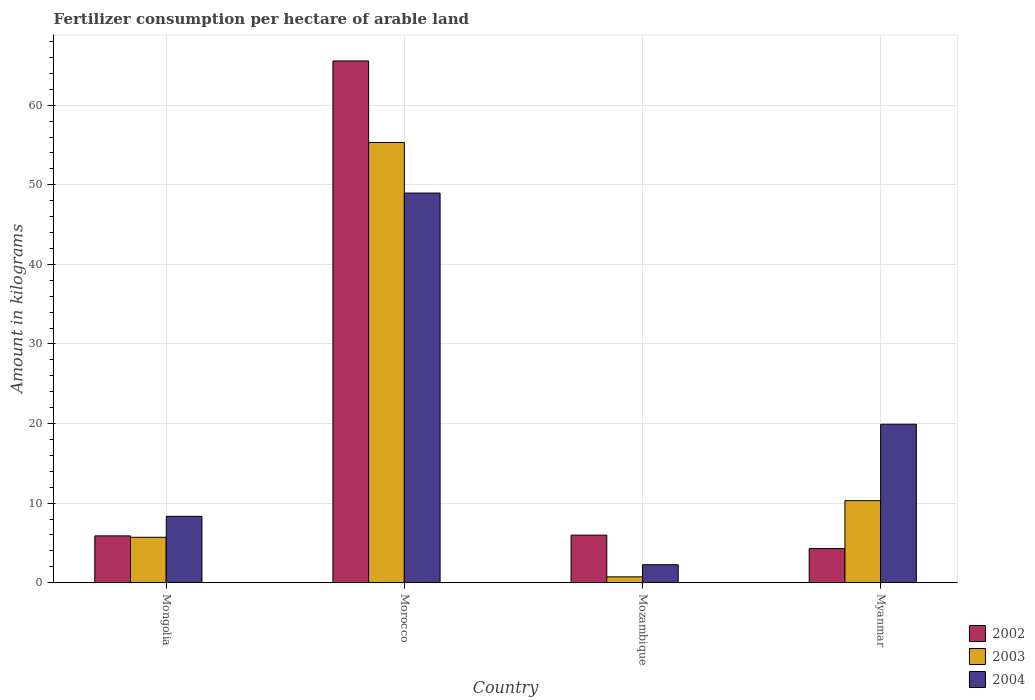How many different coloured bars are there?
Offer a terse response. 3. Are the number of bars per tick equal to the number of legend labels?
Give a very brief answer. Yes. How many bars are there on the 1st tick from the left?
Make the answer very short. 3. What is the label of the 3rd group of bars from the left?
Provide a succinct answer. Mozambique. In how many cases, is the number of bars for a given country not equal to the number of legend labels?
Keep it short and to the point. 0. What is the amount of fertilizer consumption in 2003 in Myanmar?
Give a very brief answer. 10.31. Across all countries, what is the maximum amount of fertilizer consumption in 2004?
Your answer should be compact. 48.96. Across all countries, what is the minimum amount of fertilizer consumption in 2002?
Provide a short and direct response. 4.29. In which country was the amount of fertilizer consumption in 2004 maximum?
Your answer should be very brief. Morocco. In which country was the amount of fertilizer consumption in 2004 minimum?
Offer a terse response. Mozambique. What is the total amount of fertilizer consumption in 2004 in the graph?
Your answer should be very brief. 79.47. What is the difference between the amount of fertilizer consumption in 2004 in Mongolia and that in Mozambique?
Your answer should be compact. 6.08. What is the difference between the amount of fertilizer consumption in 2003 in Morocco and the amount of fertilizer consumption in 2002 in Mongolia?
Offer a terse response. 49.43. What is the average amount of fertilizer consumption in 2002 per country?
Your answer should be very brief. 20.43. What is the difference between the amount of fertilizer consumption of/in 2003 and amount of fertilizer consumption of/in 2002 in Mozambique?
Give a very brief answer. -5.24. In how many countries, is the amount of fertilizer consumption in 2004 greater than 52 kg?
Provide a short and direct response. 0. What is the ratio of the amount of fertilizer consumption in 2003 in Morocco to that in Myanmar?
Provide a short and direct response. 5.37. Is the amount of fertilizer consumption in 2002 in Mongolia less than that in Myanmar?
Make the answer very short. No. What is the difference between the highest and the second highest amount of fertilizer consumption in 2004?
Your answer should be compact. 40.62. What is the difference between the highest and the lowest amount of fertilizer consumption in 2004?
Your response must be concise. 46.7. In how many countries, is the amount of fertilizer consumption in 2003 greater than the average amount of fertilizer consumption in 2003 taken over all countries?
Your answer should be compact. 1. Is the sum of the amount of fertilizer consumption in 2002 in Mongolia and Morocco greater than the maximum amount of fertilizer consumption in 2004 across all countries?
Give a very brief answer. Yes. What does the 3rd bar from the left in Mongolia represents?
Ensure brevity in your answer.  2004. What does the 3rd bar from the right in Myanmar represents?
Provide a succinct answer. 2002. Is it the case that in every country, the sum of the amount of fertilizer consumption in 2004 and amount of fertilizer consumption in 2002 is greater than the amount of fertilizer consumption in 2003?
Make the answer very short. Yes. What is the difference between two consecutive major ticks on the Y-axis?
Your answer should be compact. 10. Are the values on the major ticks of Y-axis written in scientific E-notation?
Your answer should be very brief. No. Does the graph contain any zero values?
Offer a very short reply. No. How many legend labels are there?
Ensure brevity in your answer.  3. What is the title of the graph?
Provide a succinct answer. Fertilizer consumption per hectare of arable land. Does "2011" appear as one of the legend labels in the graph?
Provide a succinct answer. No. What is the label or title of the Y-axis?
Make the answer very short. Amount in kilograms. What is the Amount in kilograms of 2002 in Mongolia?
Provide a short and direct response. 5.88. What is the Amount in kilograms of 2003 in Mongolia?
Offer a very short reply. 5.71. What is the Amount in kilograms in 2004 in Mongolia?
Offer a very short reply. 8.34. What is the Amount in kilograms of 2002 in Morocco?
Your answer should be very brief. 65.55. What is the Amount in kilograms of 2003 in Morocco?
Offer a terse response. 55.31. What is the Amount in kilograms of 2004 in Morocco?
Your response must be concise. 48.96. What is the Amount in kilograms of 2002 in Mozambique?
Ensure brevity in your answer.  5.98. What is the Amount in kilograms in 2003 in Mozambique?
Give a very brief answer. 0.74. What is the Amount in kilograms in 2004 in Mozambique?
Ensure brevity in your answer.  2.26. What is the Amount in kilograms of 2002 in Myanmar?
Offer a terse response. 4.29. What is the Amount in kilograms in 2003 in Myanmar?
Offer a very short reply. 10.31. What is the Amount in kilograms of 2004 in Myanmar?
Your answer should be very brief. 19.91. Across all countries, what is the maximum Amount in kilograms of 2002?
Provide a succinct answer. 65.55. Across all countries, what is the maximum Amount in kilograms of 2003?
Offer a very short reply. 55.31. Across all countries, what is the maximum Amount in kilograms of 2004?
Keep it short and to the point. 48.96. Across all countries, what is the minimum Amount in kilograms in 2002?
Keep it short and to the point. 4.29. Across all countries, what is the minimum Amount in kilograms in 2003?
Your answer should be very brief. 0.74. Across all countries, what is the minimum Amount in kilograms of 2004?
Offer a terse response. 2.26. What is the total Amount in kilograms in 2002 in the graph?
Keep it short and to the point. 81.71. What is the total Amount in kilograms in 2003 in the graph?
Your answer should be very brief. 72.06. What is the total Amount in kilograms in 2004 in the graph?
Your response must be concise. 79.47. What is the difference between the Amount in kilograms in 2002 in Mongolia and that in Morocco?
Offer a very short reply. -59.67. What is the difference between the Amount in kilograms in 2003 in Mongolia and that in Morocco?
Provide a short and direct response. -49.61. What is the difference between the Amount in kilograms of 2004 in Mongolia and that in Morocco?
Your answer should be very brief. -40.62. What is the difference between the Amount in kilograms in 2002 in Mongolia and that in Mozambique?
Provide a succinct answer. -0.09. What is the difference between the Amount in kilograms of 2003 in Mongolia and that in Mozambique?
Your answer should be compact. 4.97. What is the difference between the Amount in kilograms in 2004 in Mongolia and that in Mozambique?
Your answer should be compact. 6.08. What is the difference between the Amount in kilograms in 2002 in Mongolia and that in Myanmar?
Ensure brevity in your answer.  1.59. What is the difference between the Amount in kilograms of 2003 in Mongolia and that in Myanmar?
Your answer should be compact. -4.6. What is the difference between the Amount in kilograms in 2004 in Mongolia and that in Myanmar?
Make the answer very short. -11.57. What is the difference between the Amount in kilograms of 2002 in Morocco and that in Mozambique?
Provide a succinct answer. 59.58. What is the difference between the Amount in kilograms of 2003 in Morocco and that in Mozambique?
Offer a terse response. 54.58. What is the difference between the Amount in kilograms in 2004 in Morocco and that in Mozambique?
Provide a short and direct response. 46.7. What is the difference between the Amount in kilograms of 2002 in Morocco and that in Myanmar?
Keep it short and to the point. 61.26. What is the difference between the Amount in kilograms in 2003 in Morocco and that in Myanmar?
Offer a terse response. 45. What is the difference between the Amount in kilograms in 2004 in Morocco and that in Myanmar?
Offer a terse response. 29.05. What is the difference between the Amount in kilograms of 2002 in Mozambique and that in Myanmar?
Offer a very short reply. 1.69. What is the difference between the Amount in kilograms in 2003 in Mozambique and that in Myanmar?
Offer a terse response. -9.57. What is the difference between the Amount in kilograms of 2004 in Mozambique and that in Myanmar?
Offer a very short reply. -17.65. What is the difference between the Amount in kilograms of 2002 in Mongolia and the Amount in kilograms of 2003 in Morocco?
Provide a short and direct response. -49.43. What is the difference between the Amount in kilograms of 2002 in Mongolia and the Amount in kilograms of 2004 in Morocco?
Keep it short and to the point. -43.07. What is the difference between the Amount in kilograms of 2003 in Mongolia and the Amount in kilograms of 2004 in Morocco?
Your answer should be compact. -43.25. What is the difference between the Amount in kilograms in 2002 in Mongolia and the Amount in kilograms in 2003 in Mozambique?
Give a very brief answer. 5.15. What is the difference between the Amount in kilograms of 2002 in Mongolia and the Amount in kilograms of 2004 in Mozambique?
Your answer should be very brief. 3.62. What is the difference between the Amount in kilograms of 2003 in Mongolia and the Amount in kilograms of 2004 in Mozambique?
Give a very brief answer. 3.45. What is the difference between the Amount in kilograms in 2002 in Mongolia and the Amount in kilograms in 2003 in Myanmar?
Keep it short and to the point. -4.43. What is the difference between the Amount in kilograms of 2002 in Mongolia and the Amount in kilograms of 2004 in Myanmar?
Your response must be concise. -14.03. What is the difference between the Amount in kilograms in 2003 in Mongolia and the Amount in kilograms in 2004 in Myanmar?
Keep it short and to the point. -14.21. What is the difference between the Amount in kilograms of 2002 in Morocco and the Amount in kilograms of 2003 in Mozambique?
Provide a short and direct response. 64.82. What is the difference between the Amount in kilograms in 2002 in Morocco and the Amount in kilograms in 2004 in Mozambique?
Your answer should be very brief. 63.29. What is the difference between the Amount in kilograms of 2003 in Morocco and the Amount in kilograms of 2004 in Mozambique?
Offer a terse response. 53.05. What is the difference between the Amount in kilograms in 2002 in Morocco and the Amount in kilograms in 2003 in Myanmar?
Your answer should be very brief. 55.25. What is the difference between the Amount in kilograms of 2002 in Morocco and the Amount in kilograms of 2004 in Myanmar?
Your answer should be compact. 45.64. What is the difference between the Amount in kilograms in 2003 in Morocco and the Amount in kilograms in 2004 in Myanmar?
Provide a short and direct response. 35.4. What is the difference between the Amount in kilograms in 2002 in Mozambique and the Amount in kilograms in 2003 in Myanmar?
Your answer should be compact. -4.33. What is the difference between the Amount in kilograms of 2002 in Mozambique and the Amount in kilograms of 2004 in Myanmar?
Ensure brevity in your answer.  -13.93. What is the difference between the Amount in kilograms in 2003 in Mozambique and the Amount in kilograms in 2004 in Myanmar?
Keep it short and to the point. -19.18. What is the average Amount in kilograms in 2002 per country?
Your response must be concise. 20.43. What is the average Amount in kilograms in 2003 per country?
Provide a succinct answer. 18.02. What is the average Amount in kilograms of 2004 per country?
Offer a very short reply. 19.87. What is the difference between the Amount in kilograms of 2002 and Amount in kilograms of 2003 in Mongolia?
Offer a terse response. 0.18. What is the difference between the Amount in kilograms of 2002 and Amount in kilograms of 2004 in Mongolia?
Offer a terse response. -2.46. What is the difference between the Amount in kilograms of 2003 and Amount in kilograms of 2004 in Mongolia?
Offer a terse response. -2.64. What is the difference between the Amount in kilograms in 2002 and Amount in kilograms in 2003 in Morocco?
Ensure brevity in your answer.  10.24. What is the difference between the Amount in kilograms in 2002 and Amount in kilograms in 2004 in Morocco?
Make the answer very short. 16.6. What is the difference between the Amount in kilograms in 2003 and Amount in kilograms in 2004 in Morocco?
Ensure brevity in your answer.  6.35. What is the difference between the Amount in kilograms of 2002 and Amount in kilograms of 2003 in Mozambique?
Offer a very short reply. 5.24. What is the difference between the Amount in kilograms of 2002 and Amount in kilograms of 2004 in Mozambique?
Provide a succinct answer. 3.72. What is the difference between the Amount in kilograms in 2003 and Amount in kilograms in 2004 in Mozambique?
Provide a succinct answer. -1.52. What is the difference between the Amount in kilograms in 2002 and Amount in kilograms in 2003 in Myanmar?
Provide a short and direct response. -6.02. What is the difference between the Amount in kilograms of 2002 and Amount in kilograms of 2004 in Myanmar?
Offer a very short reply. -15.62. What is the difference between the Amount in kilograms of 2003 and Amount in kilograms of 2004 in Myanmar?
Offer a terse response. -9.6. What is the ratio of the Amount in kilograms of 2002 in Mongolia to that in Morocco?
Offer a very short reply. 0.09. What is the ratio of the Amount in kilograms in 2003 in Mongolia to that in Morocco?
Your answer should be compact. 0.1. What is the ratio of the Amount in kilograms in 2004 in Mongolia to that in Morocco?
Provide a succinct answer. 0.17. What is the ratio of the Amount in kilograms of 2002 in Mongolia to that in Mozambique?
Ensure brevity in your answer.  0.98. What is the ratio of the Amount in kilograms in 2003 in Mongolia to that in Mozambique?
Your answer should be very brief. 7.75. What is the ratio of the Amount in kilograms of 2004 in Mongolia to that in Mozambique?
Provide a succinct answer. 3.69. What is the ratio of the Amount in kilograms of 2002 in Mongolia to that in Myanmar?
Your answer should be compact. 1.37. What is the ratio of the Amount in kilograms in 2003 in Mongolia to that in Myanmar?
Provide a short and direct response. 0.55. What is the ratio of the Amount in kilograms in 2004 in Mongolia to that in Myanmar?
Offer a very short reply. 0.42. What is the ratio of the Amount in kilograms in 2002 in Morocco to that in Mozambique?
Ensure brevity in your answer.  10.97. What is the ratio of the Amount in kilograms in 2003 in Morocco to that in Mozambique?
Your answer should be very brief. 75.13. What is the ratio of the Amount in kilograms of 2004 in Morocco to that in Mozambique?
Keep it short and to the point. 21.66. What is the ratio of the Amount in kilograms of 2002 in Morocco to that in Myanmar?
Ensure brevity in your answer.  15.28. What is the ratio of the Amount in kilograms in 2003 in Morocco to that in Myanmar?
Keep it short and to the point. 5.37. What is the ratio of the Amount in kilograms of 2004 in Morocco to that in Myanmar?
Provide a succinct answer. 2.46. What is the ratio of the Amount in kilograms of 2002 in Mozambique to that in Myanmar?
Your response must be concise. 1.39. What is the ratio of the Amount in kilograms in 2003 in Mozambique to that in Myanmar?
Your answer should be very brief. 0.07. What is the ratio of the Amount in kilograms in 2004 in Mozambique to that in Myanmar?
Your response must be concise. 0.11. What is the difference between the highest and the second highest Amount in kilograms in 2002?
Offer a very short reply. 59.58. What is the difference between the highest and the second highest Amount in kilograms in 2003?
Provide a short and direct response. 45. What is the difference between the highest and the second highest Amount in kilograms of 2004?
Your response must be concise. 29.05. What is the difference between the highest and the lowest Amount in kilograms of 2002?
Provide a short and direct response. 61.26. What is the difference between the highest and the lowest Amount in kilograms in 2003?
Make the answer very short. 54.58. What is the difference between the highest and the lowest Amount in kilograms in 2004?
Your answer should be compact. 46.7. 